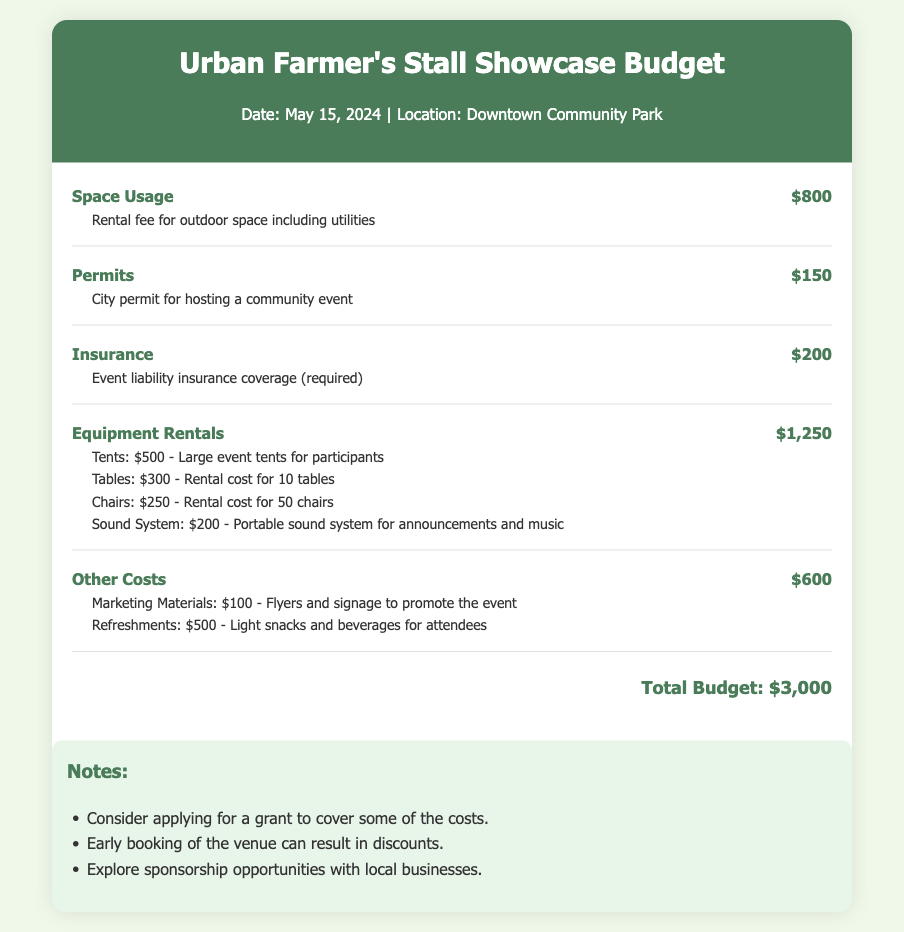What is the total budget for the event? The total budget is listed at the bottom of the document and represents the cumulative costs of all items.
Answer: $3,000 How much is the space usage cost? The space usage cost is shown as a separate line item detailing the rental fee for the outdoor space.
Answer: $800 What is the cost of permits? The cost is explicitly mentioned in the budget and refers to the fee for obtaining a permit to host the event.
Answer: $150 What is included in equipment rentals? The document outlines various items, including tents, tables, chairs, and sound systems, along with their individual costs.
Answer: Tents, Tables, Chairs, Sound System What is the cost of insurance? This is a specified expense in the budget that relates to necessary coverage for the event liability.
Answer: $200 How much is allocated for marketing materials? The budget breaks down costs for different categories, including marketing materials as a distinct item.
Answer: $100 What is the cost for refreshments? This cost is included under "Other Costs" and pertains to items provided for attendees during the event.
Answer: $500 What is a suggested way to reduce costs mentioned in the notes? The notes section provides recommendations that can help in lowering expenses related to the event.
Answer: Applying for a grant What venue is chosen for the event? The location is detailed in the header, specifying where the event will take place on the given date.
Answer: Downtown Community Park 